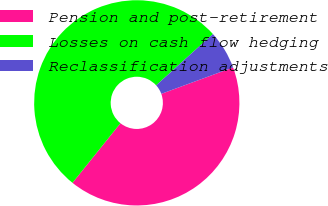<chart> <loc_0><loc_0><loc_500><loc_500><pie_chart><fcel>Pension and post-retirement<fcel>Losses on cash flow hedging<fcel>Reclassification adjustments<nl><fcel>41.39%<fcel>52.52%<fcel>6.09%<nl></chart> 